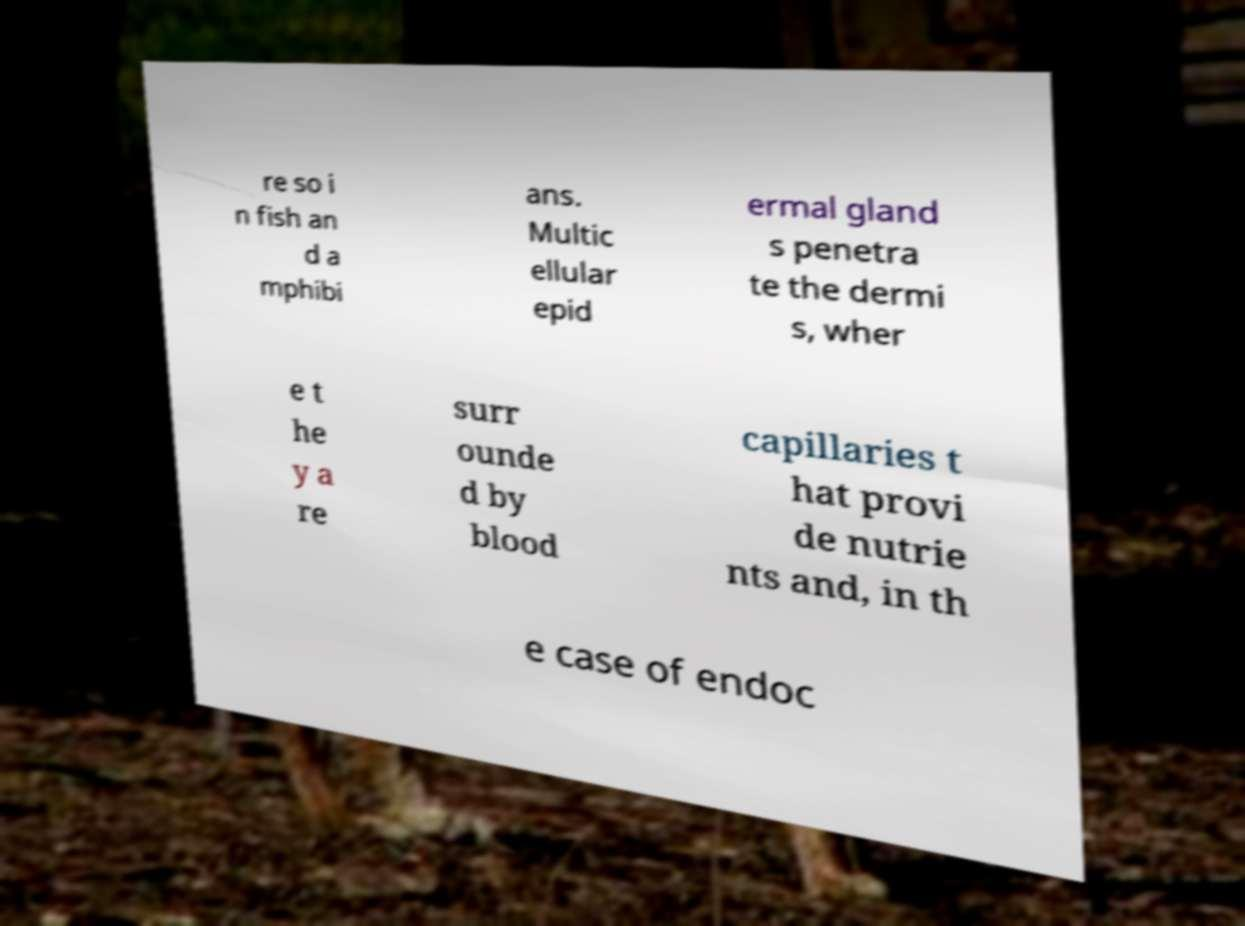Can you read and provide the text displayed in the image?This photo seems to have some interesting text. Can you extract and type it out for me? re so i n fish an d a mphibi ans. Multic ellular epid ermal gland s penetra te the dermi s, wher e t he y a re surr ounde d by blood capillaries t hat provi de nutrie nts and, in th e case of endoc 